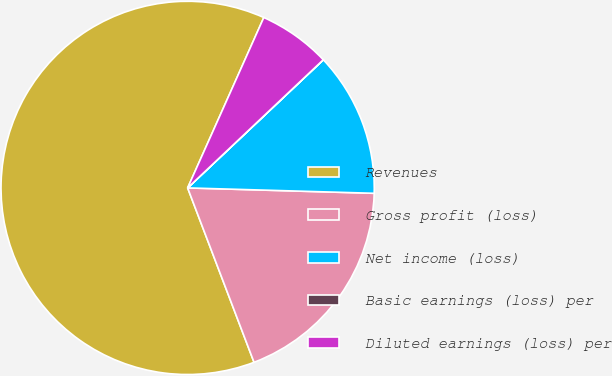<chart> <loc_0><loc_0><loc_500><loc_500><pie_chart><fcel>Revenues<fcel>Gross profit (loss)<fcel>Net income (loss)<fcel>Basic earnings (loss) per<fcel>Diluted earnings (loss) per<nl><fcel>62.48%<fcel>18.75%<fcel>12.5%<fcel>0.01%<fcel>6.26%<nl></chart> 